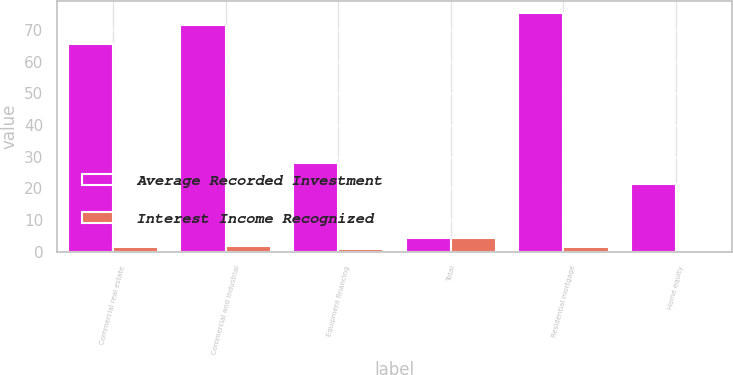Convert chart. <chart><loc_0><loc_0><loc_500><loc_500><stacked_bar_chart><ecel><fcel>Commercial real estate<fcel>Commercial and industrial<fcel>Equipment financing<fcel>Total<fcel>Residential mortgage<fcel>Home equity<nl><fcel>Average Recorded Investment<fcel>65.6<fcel>71.6<fcel>28<fcel>4.3<fcel>75.2<fcel>21.2<nl><fcel>Interest Income Recognized<fcel>1.6<fcel>1.8<fcel>0.9<fcel>4.3<fcel>1.5<fcel>0.3<nl></chart> 